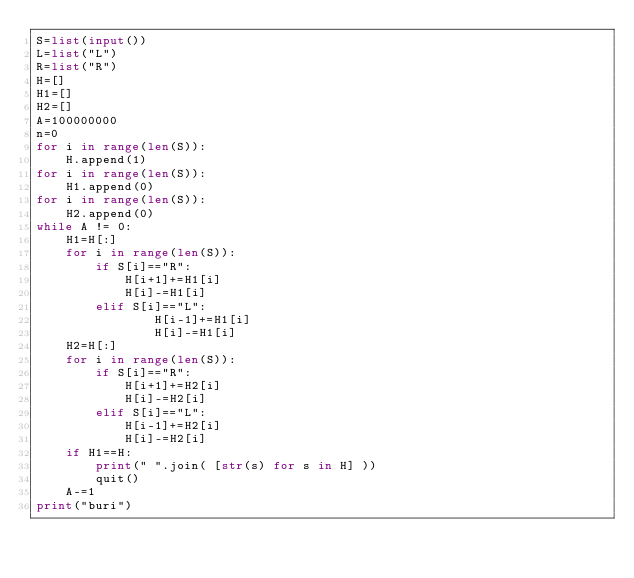<code> <loc_0><loc_0><loc_500><loc_500><_Python_>S=list(input())
L=list("L")
R=list("R")
H=[]
H1=[]
H2=[]
A=100000000
n=0
for i in range(len(S)):
    H.append(1)
for i in range(len(S)):
    H1.append(0)
for i in range(len(S)):
    H2.append(0)
while A != 0:
    H1=H[:]
    for i in range(len(S)):
        if S[i]=="R":
            H[i+1]+=H1[i]
            H[i]-=H1[i]
        elif S[i]=="L":
                H[i-1]+=H1[i]
                H[i]-=H1[i]
    H2=H[:]
    for i in range(len(S)):
        if S[i]=="R":
            H[i+1]+=H2[i]
            H[i]-=H2[i]
        elif S[i]=="L":
            H[i-1]+=H2[i]
            H[i]-=H2[i]
    if H1==H:
        print(" ".join( [str(s) for s in H] ))
        quit()
    A-=1
print("buri")
</code> 